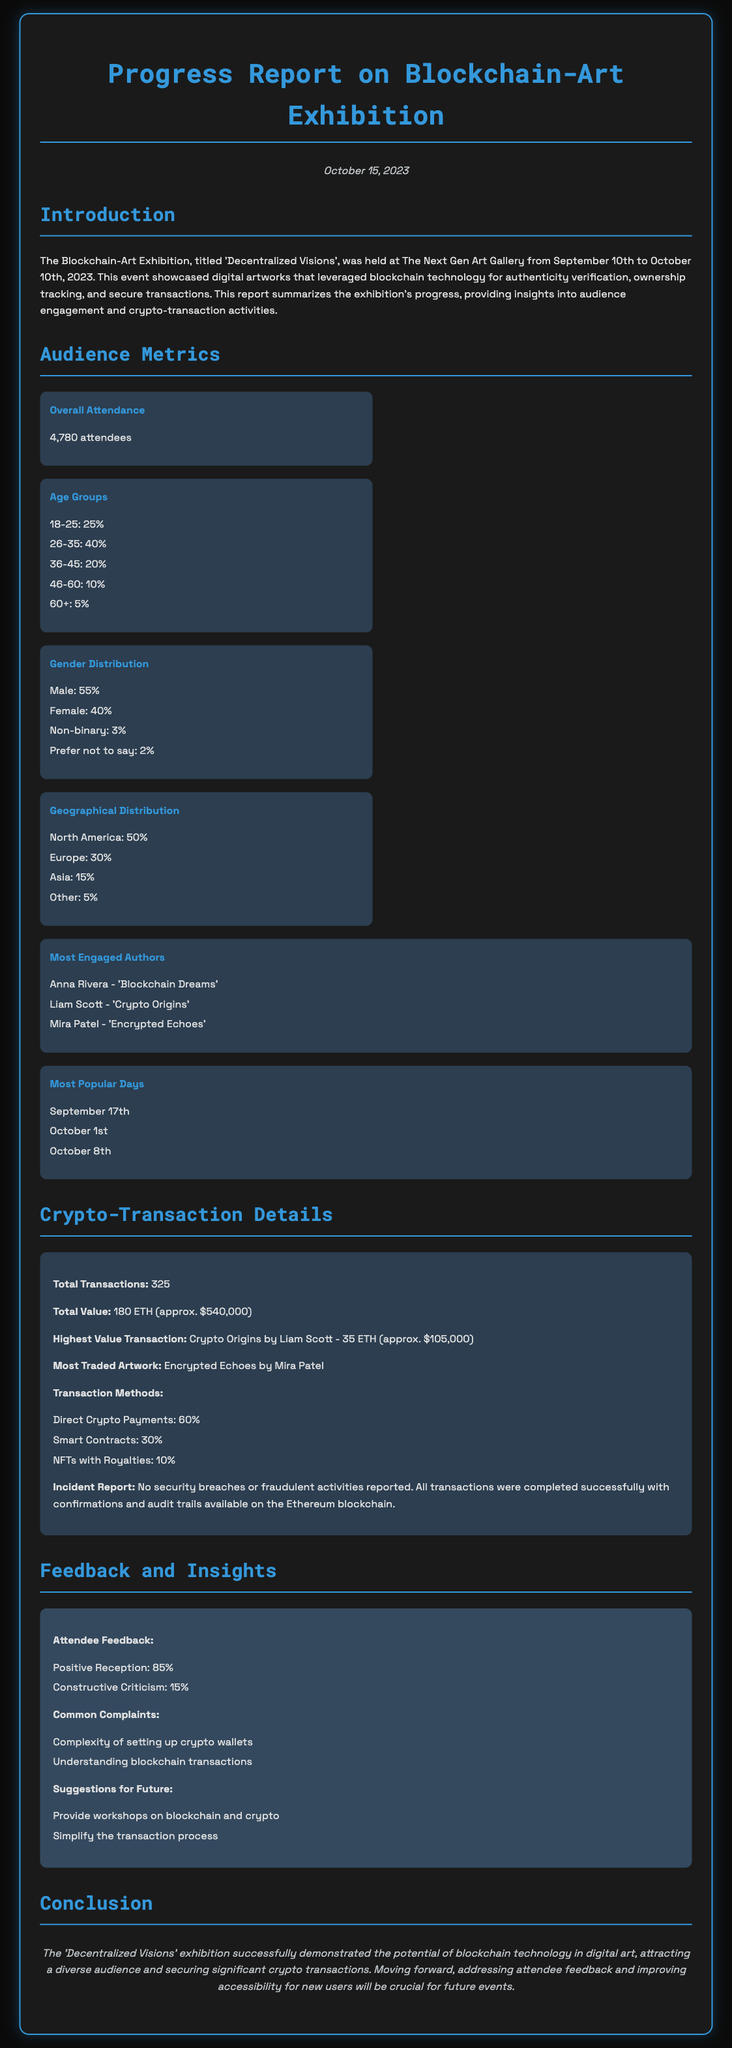What was the overall attendance at the exhibition? The overall attendance is detailed in the audience metrics section of the document, which states that there were 4,780 attendees.
Answer: 4,780 attendees What percentage of attendees were aged 26-35? This percentage is listed under the age groups in the audience metrics section, which shows that 40% of attendees were 26-35 years old.
Answer: 40% Who is the author of the artwork "Crypto Origins"? The author of "Crypto Origins" is specifically mentioned in the most engaged authors list.
Answer: Liam Scott What is the highest value transaction recorded during the exhibition? The highest value transaction is summarized in the crypto-transaction details section, which notes it was 35 ETH.
Answer: 35 ETH What was the total value of all transactions in the exhibition? This total value can be found in the crypto-transaction details section, which indicates that it was 180 ETH (approx. $540,000).
Answer: 180 ETH (approx. $540,000) What was the most popular day of the exhibition? The most popular days are listed under the most popular days section, one of which is September 17th.
Answer: September 17th What percentage of feedback was positive? The document states that 85% of the feedback received was positive, as detailed in the feedback and insights section.
Answer: 85% What suggestion was made for future events? One specific suggestion for future events is noted as providing workshops on blockchain and crypto.
Answer: Provide workshops on blockchain and crypto What was the incident report conclusion? The incident report specifically states there were no security breaches or fraudulent activities reported.
Answer: No security breaches or fraudulent activities reported 